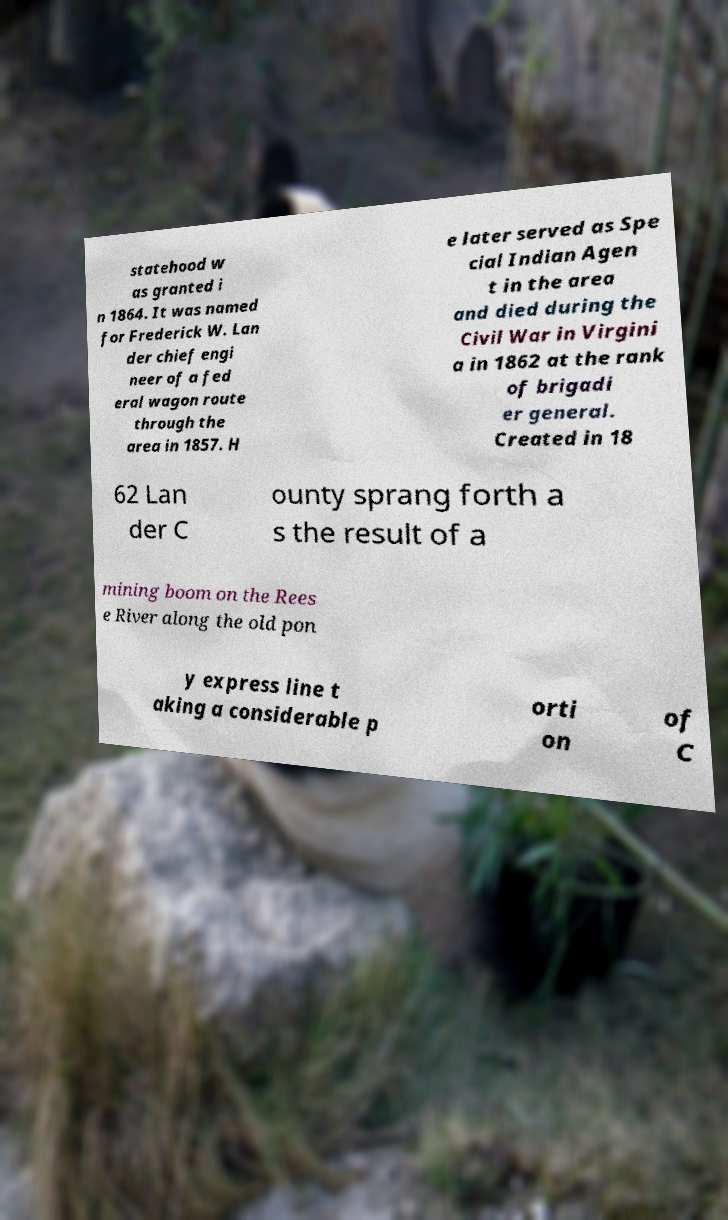I need the written content from this picture converted into text. Can you do that? statehood w as granted i n 1864. It was named for Frederick W. Lan der chief engi neer of a fed eral wagon route through the area in 1857. H e later served as Spe cial Indian Agen t in the area and died during the Civil War in Virgini a in 1862 at the rank of brigadi er general. Created in 18 62 Lan der C ounty sprang forth a s the result of a mining boom on the Rees e River along the old pon y express line t aking a considerable p orti on of C 